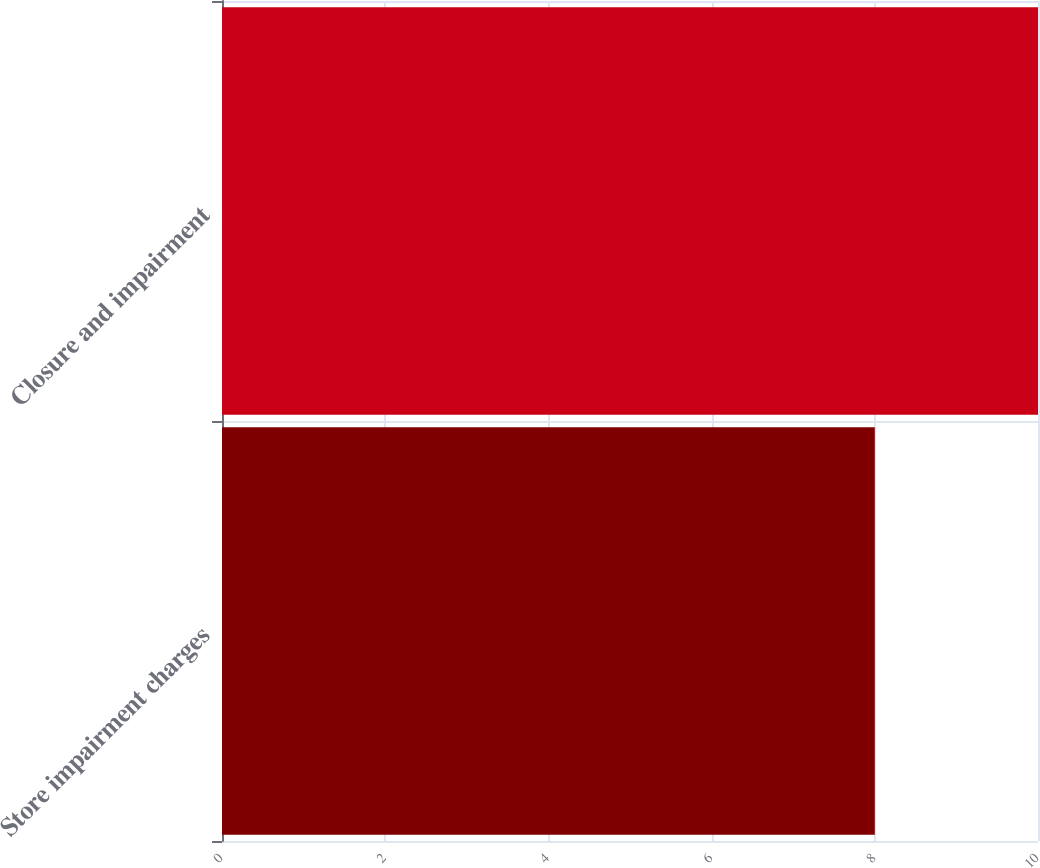Convert chart. <chart><loc_0><loc_0><loc_500><loc_500><bar_chart><fcel>Store impairment charges<fcel>Closure and impairment<nl><fcel>8<fcel>10<nl></chart> 